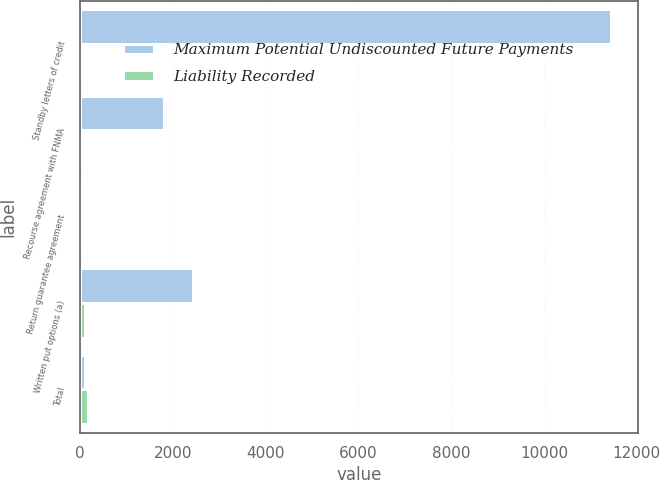Convert chart to OTSL. <chart><loc_0><loc_0><loc_500><loc_500><stacked_bar_chart><ecel><fcel>Standby letters of credit<fcel>Recourse agreement with FNMA<fcel>Return guarantee agreement<fcel>Written put options (a)<fcel>Total<nl><fcel>Maximum Potential Undiscounted Future Payments<fcel>11447<fcel>1813<fcel>4<fcel>2439<fcel>98<nl><fcel>Liability Recorded<fcel>62<fcel>4<fcel>4<fcel>98<fcel>168<nl></chart> 